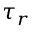Convert formula to latex. <formula><loc_0><loc_0><loc_500><loc_500>\tau _ { r }</formula> 